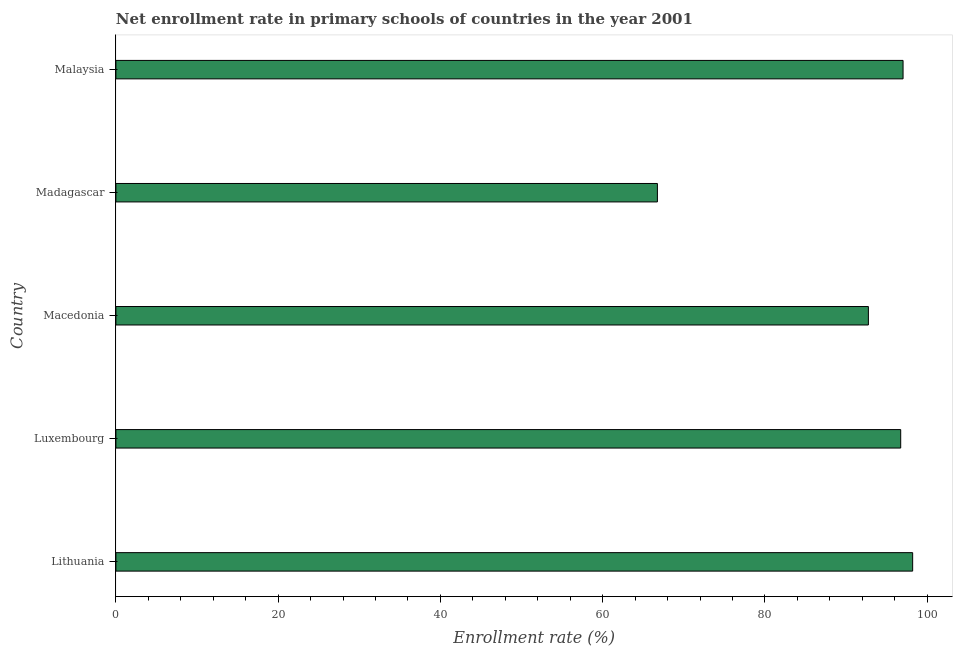What is the title of the graph?
Provide a short and direct response. Net enrollment rate in primary schools of countries in the year 2001. What is the label or title of the X-axis?
Keep it short and to the point. Enrollment rate (%). What is the label or title of the Y-axis?
Offer a very short reply. Country. What is the net enrollment rate in primary schools in Luxembourg?
Provide a short and direct response. 96.74. Across all countries, what is the maximum net enrollment rate in primary schools?
Your answer should be compact. 98.21. Across all countries, what is the minimum net enrollment rate in primary schools?
Keep it short and to the point. 66.75. In which country was the net enrollment rate in primary schools maximum?
Your response must be concise. Lithuania. In which country was the net enrollment rate in primary schools minimum?
Provide a succinct answer. Madagascar. What is the sum of the net enrollment rate in primary schools?
Your answer should be very brief. 451.48. What is the difference between the net enrollment rate in primary schools in Luxembourg and Madagascar?
Your response must be concise. 29.99. What is the average net enrollment rate in primary schools per country?
Provide a succinct answer. 90.3. What is the median net enrollment rate in primary schools?
Your answer should be very brief. 96.74. What is the ratio of the net enrollment rate in primary schools in Lithuania to that in Luxembourg?
Give a very brief answer. 1.01. Is the net enrollment rate in primary schools in Lithuania less than that in Malaysia?
Make the answer very short. No. What is the difference between the highest and the second highest net enrollment rate in primary schools?
Your answer should be very brief. 1.18. What is the difference between the highest and the lowest net enrollment rate in primary schools?
Offer a terse response. 31.46. Are all the bars in the graph horizontal?
Provide a succinct answer. Yes. How many countries are there in the graph?
Keep it short and to the point. 5. What is the difference between two consecutive major ticks on the X-axis?
Ensure brevity in your answer.  20. Are the values on the major ticks of X-axis written in scientific E-notation?
Your answer should be very brief. No. What is the Enrollment rate (%) of Lithuania?
Your answer should be very brief. 98.21. What is the Enrollment rate (%) of Luxembourg?
Offer a terse response. 96.74. What is the Enrollment rate (%) in Macedonia?
Offer a terse response. 92.75. What is the Enrollment rate (%) in Madagascar?
Ensure brevity in your answer.  66.75. What is the Enrollment rate (%) of Malaysia?
Your answer should be very brief. 97.03. What is the difference between the Enrollment rate (%) in Lithuania and Luxembourg?
Your answer should be very brief. 1.47. What is the difference between the Enrollment rate (%) in Lithuania and Macedonia?
Ensure brevity in your answer.  5.46. What is the difference between the Enrollment rate (%) in Lithuania and Madagascar?
Offer a terse response. 31.46. What is the difference between the Enrollment rate (%) in Lithuania and Malaysia?
Ensure brevity in your answer.  1.18. What is the difference between the Enrollment rate (%) in Luxembourg and Macedonia?
Offer a very short reply. 3.98. What is the difference between the Enrollment rate (%) in Luxembourg and Madagascar?
Make the answer very short. 29.99. What is the difference between the Enrollment rate (%) in Luxembourg and Malaysia?
Make the answer very short. -0.29. What is the difference between the Enrollment rate (%) in Macedonia and Madagascar?
Provide a short and direct response. 26.01. What is the difference between the Enrollment rate (%) in Macedonia and Malaysia?
Provide a succinct answer. -4.27. What is the difference between the Enrollment rate (%) in Madagascar and Malaysia?
Provide a short and direct response. -30.28. What is the ratio of the Enrollment rate (%) in Lithuania to that in Macedonia?
Provide a short and direct response. 1.06. What is the ratio of the Enrollment rate (%) in Lithuania to that in Madagascar?
Keep it short and to the point. 1.47. What is the ratio of the Enrollment rate (%) in Lithuania to that in Malaysia?
Offer a terse response. 1.01. What is the ratio of the Enrollment rate (%) in Luxembourg to that in Macedonia?
Make the answer very short. 1.04. What is the ratio of the Enrollment rate (%) in Luxembourg to that in Madagascar?
Make the answer very short. 1.45. What is the ratio of the Enrollment rate (%) in Macedonia to that in Madagascar?
Ensure brevity in your answer.  1.39. What is the ratio of the Enrollment rate (%) in Macedonia to that in Malaysia?
Your answer should be compact. 0.96. What is the ratio of the Enrollment rate (%) in Madagascar to that in Malaysia?
Your answer should be very brief. 0.69. 